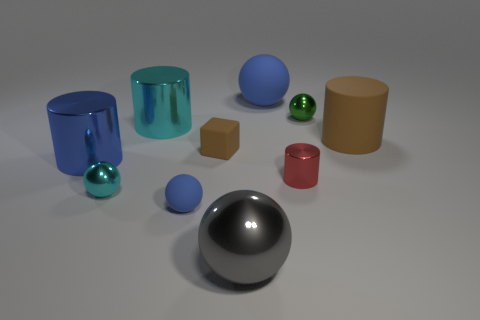What can the different textures and materials of the objects tell us about how they might feel? The various textures and materials suggest a range of tactile experiences. The smooth, shiny surfaces of the metal cylinders and spheres would likely feel cool and slick to the touch, while the matte surfaces of the blocks would have a warmer, rougher texture. These perceptual cues give us an immersive sense of how interacting with these objects might feel. Could you describe the overall atmosphere or mood the image creates due to its composition and colors? The image creates a calm and orderly atmosphere due to the carefully arranged objects and the soft, uniform lighting. The cool blue tones of the cylinders and the single vibrant green sphere add a touch of serenity, while the neutral colors of the other objects contribute to a minimalist and clean aesthetic. The overall mood is one of tranquility and balance. 